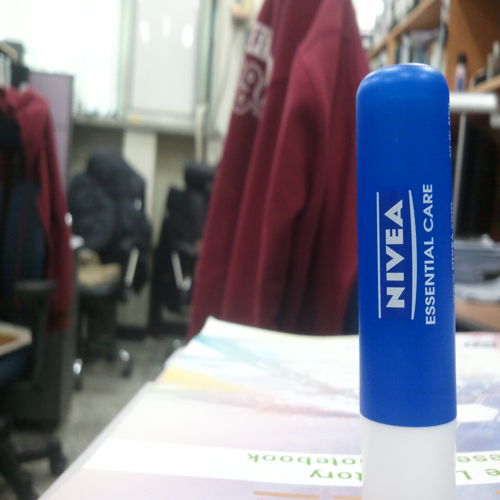How does this lip balm product stand out in this image? In the image, the Nivea Essential Care lip balm stands out due to its central placement and sharp focus against a blurry background. The bright blue cap quickly draws the viewer's attention, and the branding is instantly recognizable, making it a distinct subject within the setting. Does the image suggest anything about the context in which the lip balm is used? Although the image primarily focuses on the lip balm itself, the blurry background with what appears to be an office setting, including a person wearing a hoodie and a desk with papers, suggests that the product might be commonly used in a work or study environment for personal care during daily activities. 